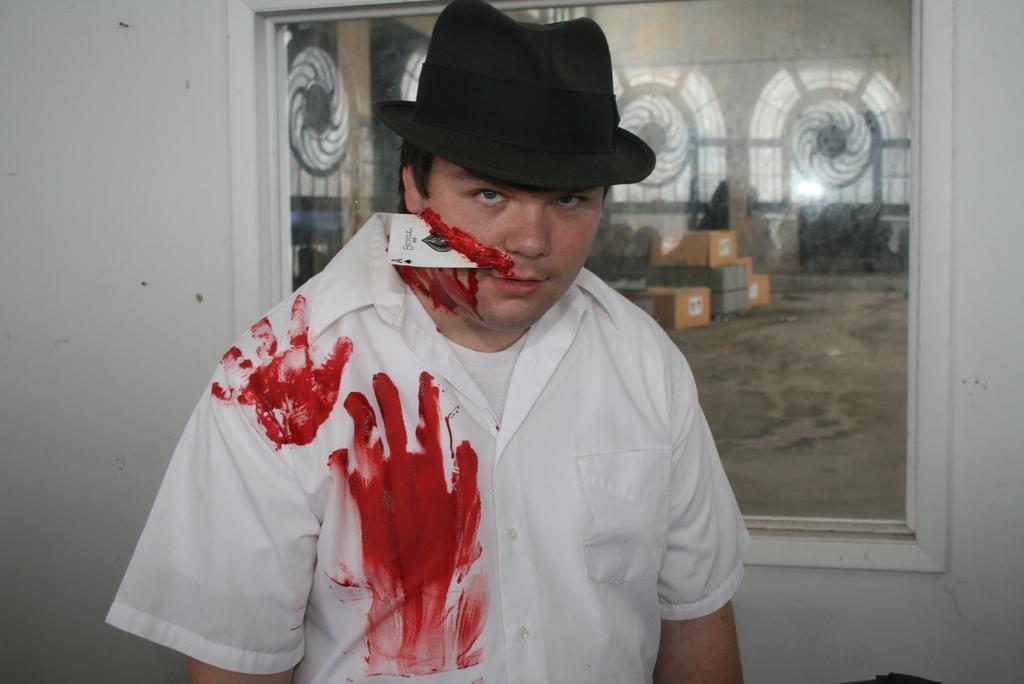In one or two sentences, can you explain what this image depicts? In this image I can see the person wearing the white color dress and the hat. I can see some red color stains on the shirt. In the background I can see the frame to the wall. In the frame I can see the cardboard boxes and the windows. 